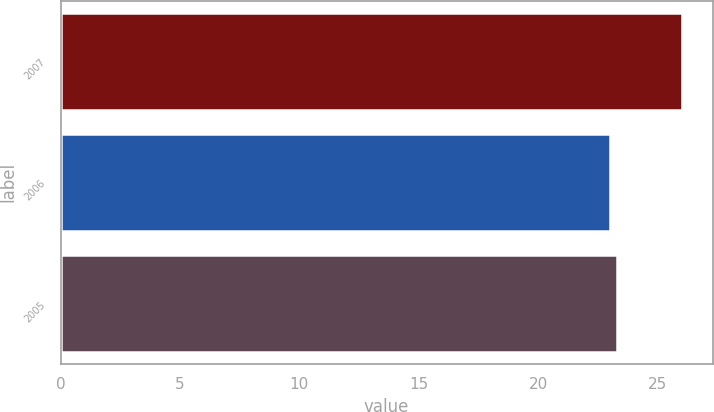<chart> <loc_0><loc_0><loc_500><loc_500><bar_chart><fcel>2007<fcel>2006<fcel>2005<nl><fcel>26<fcel>23<fcel>23.3<nl></chart> 